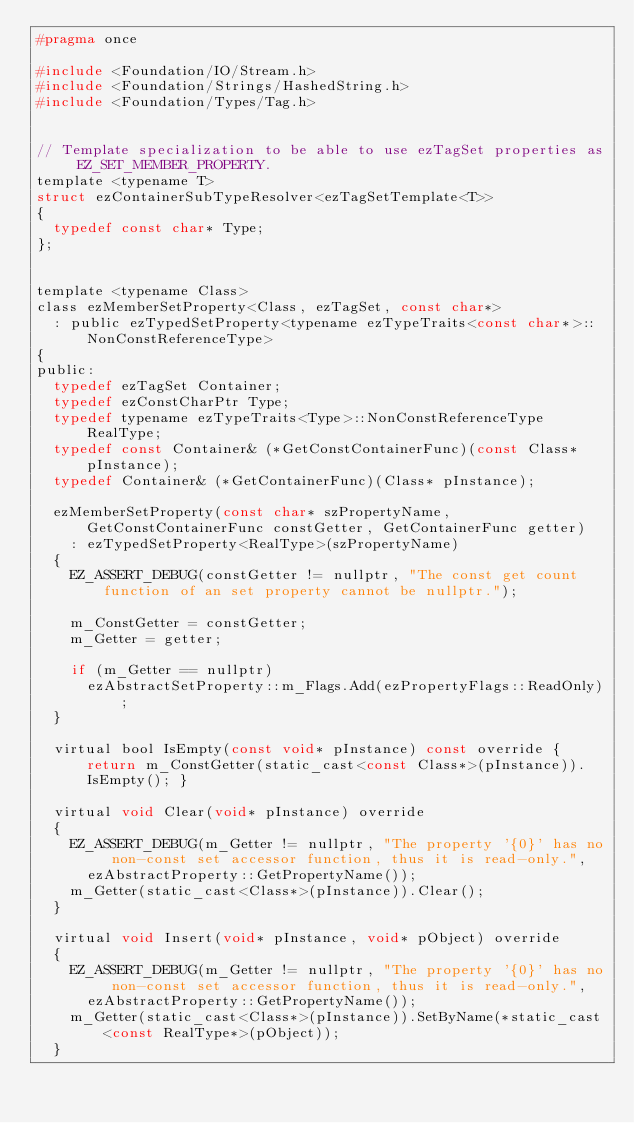<code> <loc_0><loc_0><loc_500><loc_500><_C_>#pragma once

#include <Foundation/IO/Stream.h>
#include <Foundation/Strings/HashedString.h>
#include <Foundation/Types/Tag.h>


// Template specialization to be able to use ezTagSet properties as EZ_SET_MEMBER_PROPERTY.
template <typename T>
struct ezContainerSubTypeResolver<ezTagSetTemplate<T>>
{
  typedef const char* Type;
};


template <typename Class>
class ezMemberSetProperty<Class, ezTagSet, const char*>
  : public ezTypedSetProperty<typename ezTypeTraits<const char*>::NonConstReferenceType>
{
public:
  typedef ezTagSet Container;
  typedef ezConstCharPtr Type;
  typedef typename ezTypeTraits<Type>::NonConstReferenceType RealType;
  typedef const Container& (*GetConstContainerFunc)(const Class* pInstance);
  typedef Container& (*GetContainerFunc)(Class* pInstance);

  ezMemberSetProperty(const char* szPropertyName, GetConstContainerFunc constGetter, GetContainerFunc getter)
    : ezTypedSetProperty<RealType>(szPropertyName)
  {
    EZ_ASSERT_DEBUG(constGetter != nullptr, "The const get count function of an set property cannot be nullptr.");

    m_ConstGetter = constGetter;
    m_Getter = getter;

    if (m_Getter == nullptr)
      ezAbstractSetProperty::m_Flags.Add(ezPropertyFlags::ReadOnly);
  }

  virtual bool IsEmpty(const void* pInstance) const override { return m_ConstGetter(static_cast<const Class*>(pInstance)).IsEmpty(); }

  virtual void Clear(void* pInstance) override
  {
    EZ_ASSERT_DEBUG(m_Getter != nullptr, "The property '{0}' has no non-const set accessor function, thus it is read-only.",
      ezAbstractProperty::GetPropertyName());
    m_Getter(static_cast<Class*>(pInstance)).Clear();
  }

  virtual void Insert(void* pInstance, void* pObject) override
  {
    EZ_ASSERT_DEBUG(m_Getter != nullptr, "The property '{0}' has no non-const set accessor function, thus it is read-only.",
      ezAbstractProperty::GetPropertyName());
    m_Getter(static_cast<Class*>(pInstance)).SetByName(*static_cast<const RealType*>(pObject));
  }
</code> 